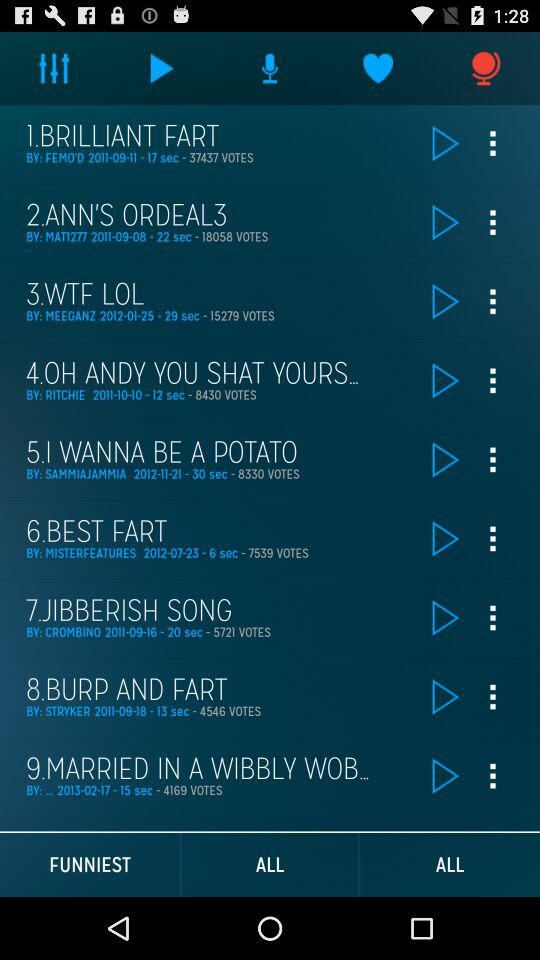Which audio track is currently selected?
When the provided information is insufficient, respond with <no answer>. <no answer> 